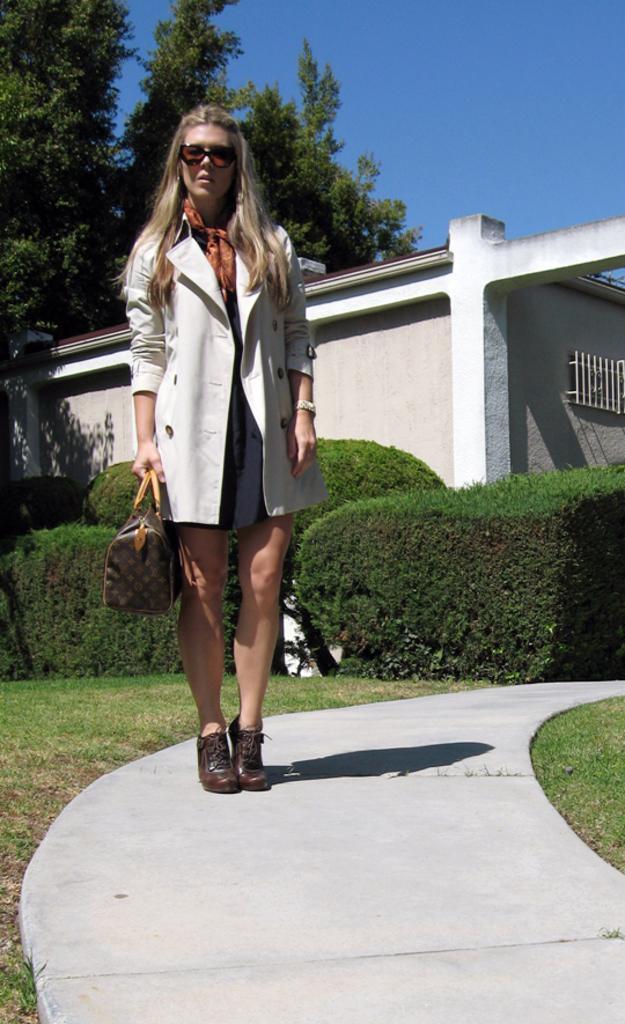Describe this image in one or two sentences. In this picture there is a woman standing on path and carrying a bag and we can see grass, hedges and wall. In the background of the image we can see trees and sky. 